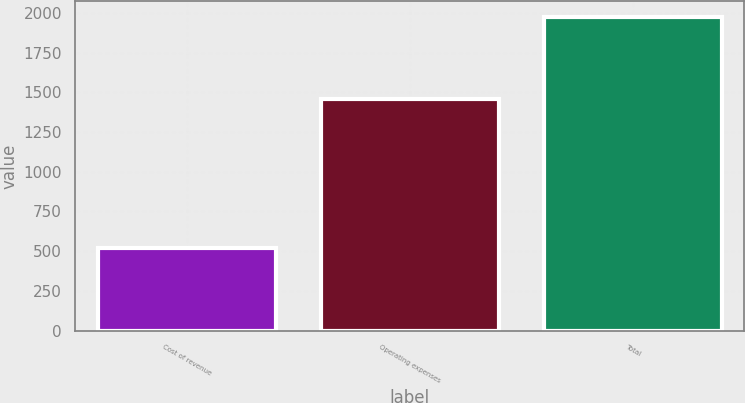<chart> <loc_0><loc_0><loc_500><loc_500><bar_chart><fcel>Cost of revenue<fcel>Operating expenses<fcel>Total<nl><fcel>518.9<fcel>1456.8<fcel>1975.7<nl></chart> 